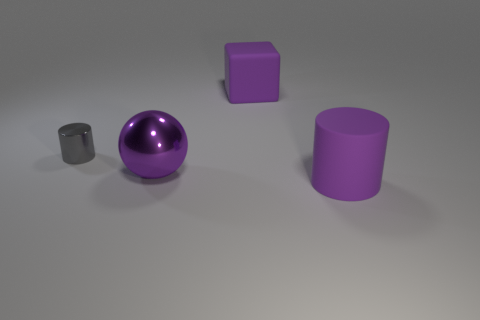Add 3 metallic balls. How many objects exist? 7 Subtract 1 blocks. How many blocks are left? 0 Subtract all balls. How many objects are left? 3 Add 1 rubber cylinders. How many rubber cylinders exist? 2 Subtract all purple cylinders. How many cylinders are left? 1 Subtract 0 gray blocks. How many objects are left? 4 Subtract all red blocks. Subtract all yellow spheres. How many blocks are left? 1 Subtract all small green shiny balls. Subtract all small gray cylinders. How many objects are left? 3 Add 4 cubes. How many cubes are left? 5 